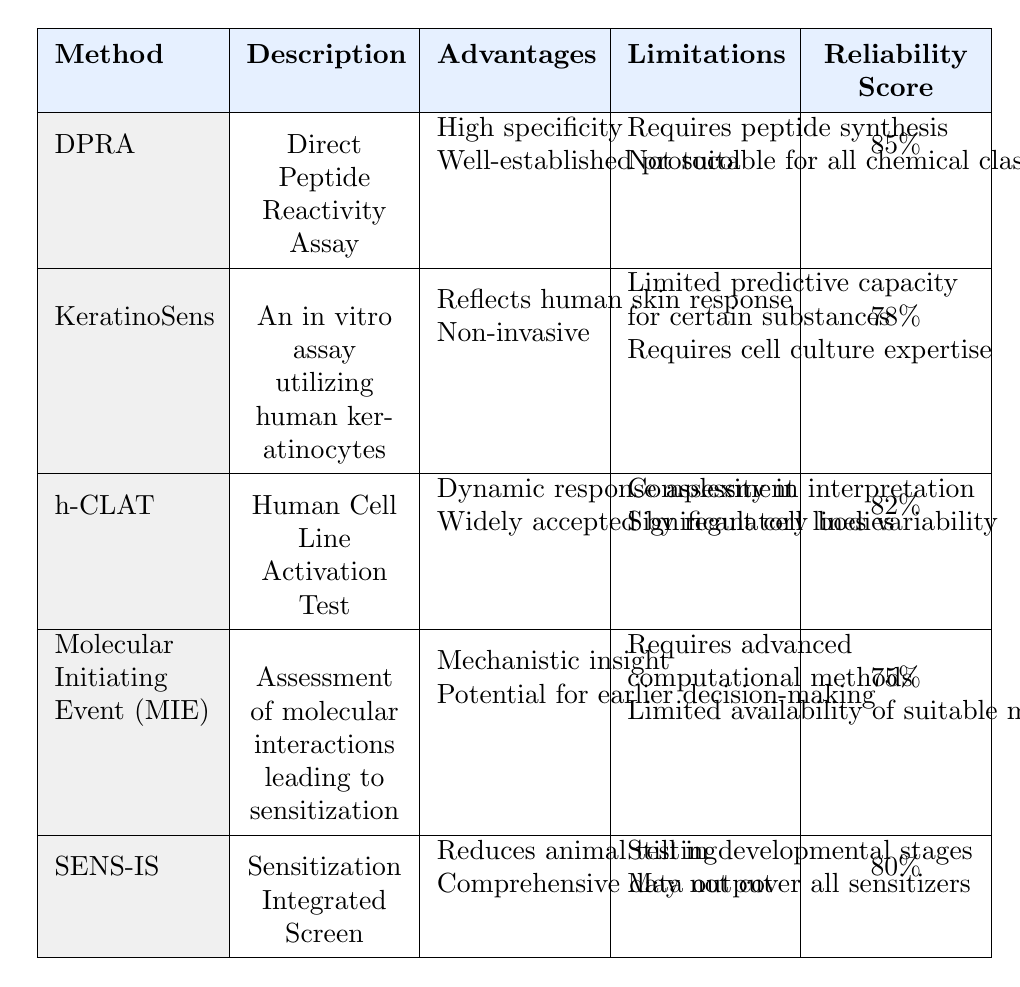What is the reliability score of the KeratinoSens method? Referring to the table, the reliability score for the KeratinoSens method is explicitly listed as 78%.
Answer: 78% Which in vitro test method has the highest reliability score? The table shows that the DPRA method has the highest reliability score at 85%.
Answer: DPRA Is there a method that reduces animal testing? Yes, the SENS-IS method explicitly states that it reduces animal testing in its advantages.
Answer: Yes What are the limitations of the h-CLAT method? The limitations for the h-CLAT method as stated in the table are complexity in interpretation and significant cell lines variability.
Answer: Complexity in interpretation and significant cell lines variability What is the average reliability score of all listed methods? The reliability scores are 85, 78, 82, 75, and 80. Adding them gives 400, and dividing by 5 gives an average of 80.
Answer: 80 Which methods require advanced computational methods? The table indicates that the Molecular Initiating Event (MIE) method requires advanced computational methods as one of its limitations.
Answer: Molecular Initiating Event (MIE) Is the DPRA method suitable for all chemical classes? The limitations listed for the DPRA method confirm that it is not suitable for all chemical classes.
Answer: No Can you list the advantages of the SENS-IS method? According to the table, the advantages of the SENS-IS method include reducing animal testing and providing comprehensive data output.
Answer: Reduces animal testing, comprehensive data output Are there any methods that are still in developmental stages? Yes, the SENS-IS method is specifically noted to be still in developmental stages in its limitations.
Answer: Yes Among the listed methods, which one reflects human skin response? The KeratinoSens method is noted as reflecting human skin response in its advantages.
Answer: KeratinoSens 